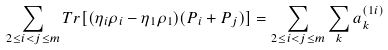Convert formula to latex. <formula><loc_0><loc_0><loc_500><loc_500>\sum _ { 2 \leq i < j \leq m } T r [ ( \eta _ { i } \rho _ { i } - \eta _ { 1 } \rho _ { 1 } ) ( P _ { i } + P _ { j } ) ] = \sum _ { 2 \leq i < j \leq m } \sum _ { k } a _ { k } ^ { ( 1 i ) }</formula> 